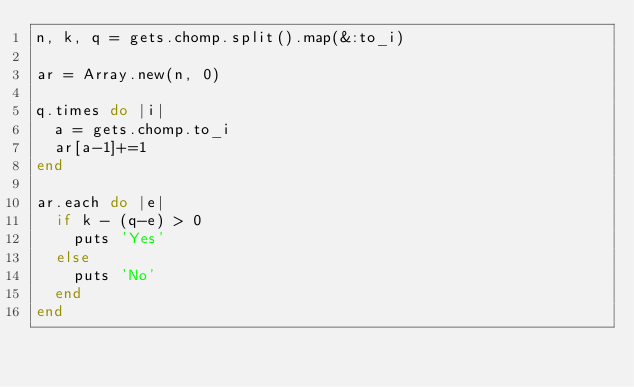<code> <loc_0><loc_0><loc_500><loc_500><_Ruby_>n, k, q = gets.chomp.split().map(&:to_i)

ar = Array.new(n, 0)

q.times do |i|
  a = gets.chomp.to_i
  ar[a-1]+=1
end

ar.each do |e|
  if k - (q-e) > 0
    puts 'Yes'
  else
    puts 'No'
  end
end</code> 